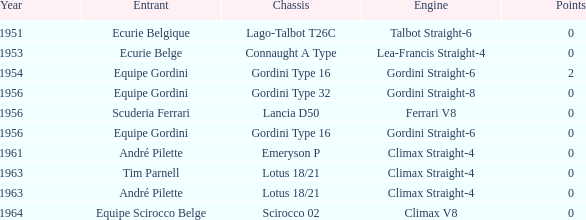Which individual or group employed the gordini straight-6 during 1956? Equipe Gordini. 